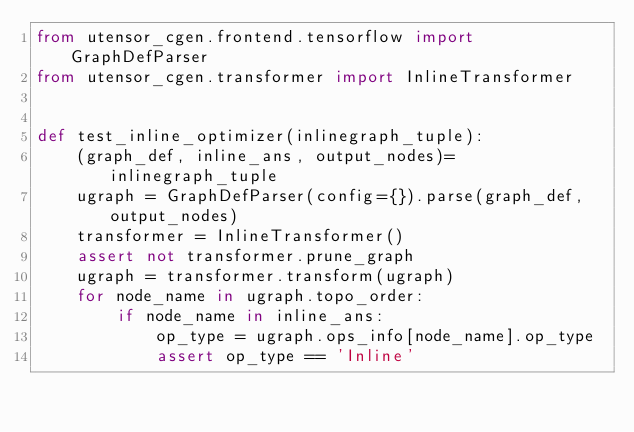<code> <loc_0><loc_0><loc_500><loc_500><_Python_>from utensor_cgen.frontend.tensorflow import GraphDefParser
from utensor_cgen.transformer import InlineTransformer


def test_inline_optimizer(inlinegraph_tuple):
    (graph_def, inline_ans, output_nodes)=  inlinegraph_tuple
    ugraph = GraphDefParser(config={}).parse(graph_def, output_nodes)
    transformer = InlineTransformer()
    assert not transformer.prune_graph
    ugraph = transformer.transform(ugraph)
    for node_name in ugraph.topo_order:
        if node_name in inline_ans:
            op_type = ugraph.ops_info[node_name].op_type
            assert op_type == 'Inline'
</code> 